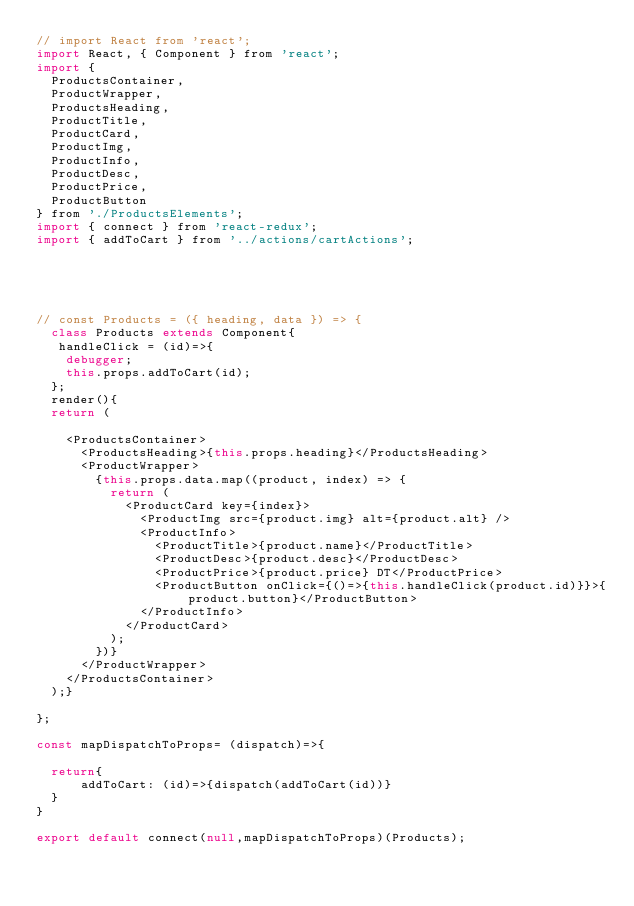<code> <loc_0><loc_0><loc_500><loc_500><_JavaScript_>// import React from 'react';
import React, { Component } from 'react';
import {
  ProductsContainer,
  ProductWrapper,
  ProductsHeading,
  ProductTitle,
  ProductCard,
  ProductImg,
  ProductInfo,
  ProductDesc,
  ProductPrice,
  ProductButton
} from './ProductsElements';
import { connect } from 'react-redux';
import { addToCart } from '../actions/cartActions';





// const Products = ({ heading, data }) => {
  class Products extends Component{
   handleClick = (id)=>{
    debugger;
    this.props.addToCart(id); 
  };
  render(){
  return (
    
    <ProductsContainer>
      <ProductsHeading>{this.props.heading}</ProductsHeading>
      <ProductWrapper>
        {this.props.data.map((product, index) => {
          return (
            <ProductCard key={index}>
              <ProductImg src={product.img} alt={product.alt} />
              <ProductInfo>
                <ProductTitle>{product.name}</ProductTitle>
                <ProductDesc>{product.desc}</ProductDesc>
                <ProductPrice>{product.price} DT</ProductPrice>
                <ProductButton onClick={()=>{this.handleClick(product.id)}}>{product.button}</ProductButton>
              </ProductInfo>
            </ProductCard>
          );
        })}
      </ProductWrapper>
    </ProductsContainer>
  );}
  
};

const mapDispatchToProps= (dispatch)=>{
    
  return{
      addToCart: (id)=>{dispatch(addToCart(id))}
  }
}

export default connect(null,mapDispatchToProps)(Products);
</code> 